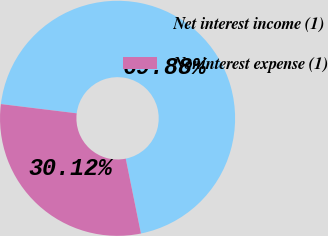Convert chart. <chart><loc_0><loc_0><loc_500><loc_500><pie_chart><fcel>Net interest income (1)<fcel>Noninterest expense (1)<nl><fcel>69.88%<fcel>30.12%<nl></chart> 